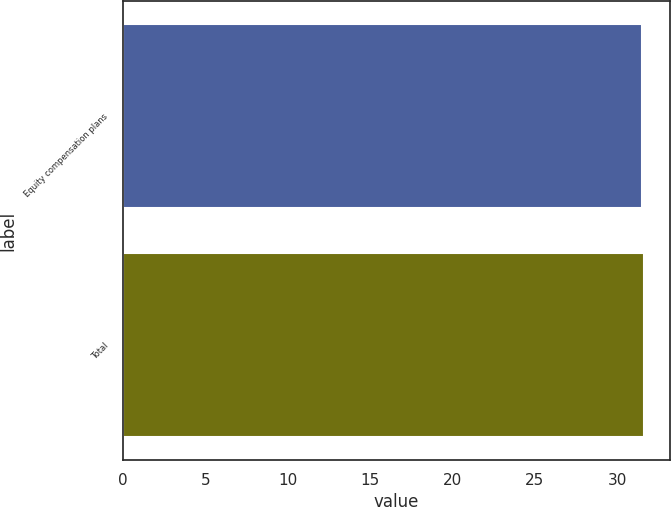<chart> <loc_0><loc_0><loc_500><loc_500><bar_chart><fcel>Equity compensation plans<fcel>Total<nl><fcel>31.5<fcel>31.6<nl></chart> 